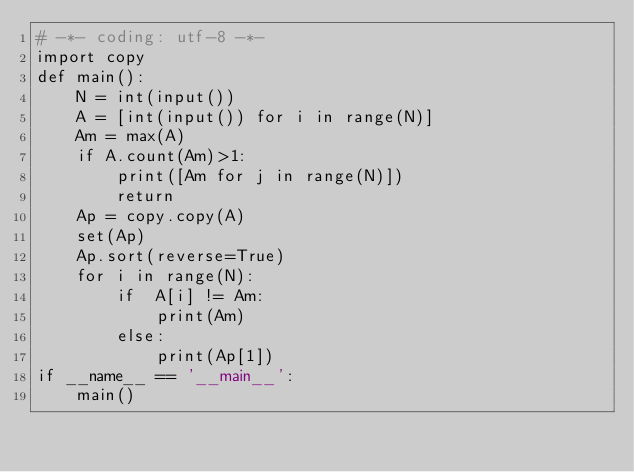<code> <loc_0><loc_0><loc_500><loc_500><_Python_># -*- coding: utf-8 -*-
import copy
def main():
    N = int(input())
    A = [int(input()) for i in range(N)]
    Am = max(A)
    if A.count(Am)>1:
        print([Am for j in range(N)])
        return
    Ap = copy.copy(A)
    set(Ap)
    Ap.sort(reverse=True)
    for i in range(N):
        if  A[i] != Am:
            print(Am)
        else:
            print(Ap[1])
if __name__ == '__main__':
    main()</code> 